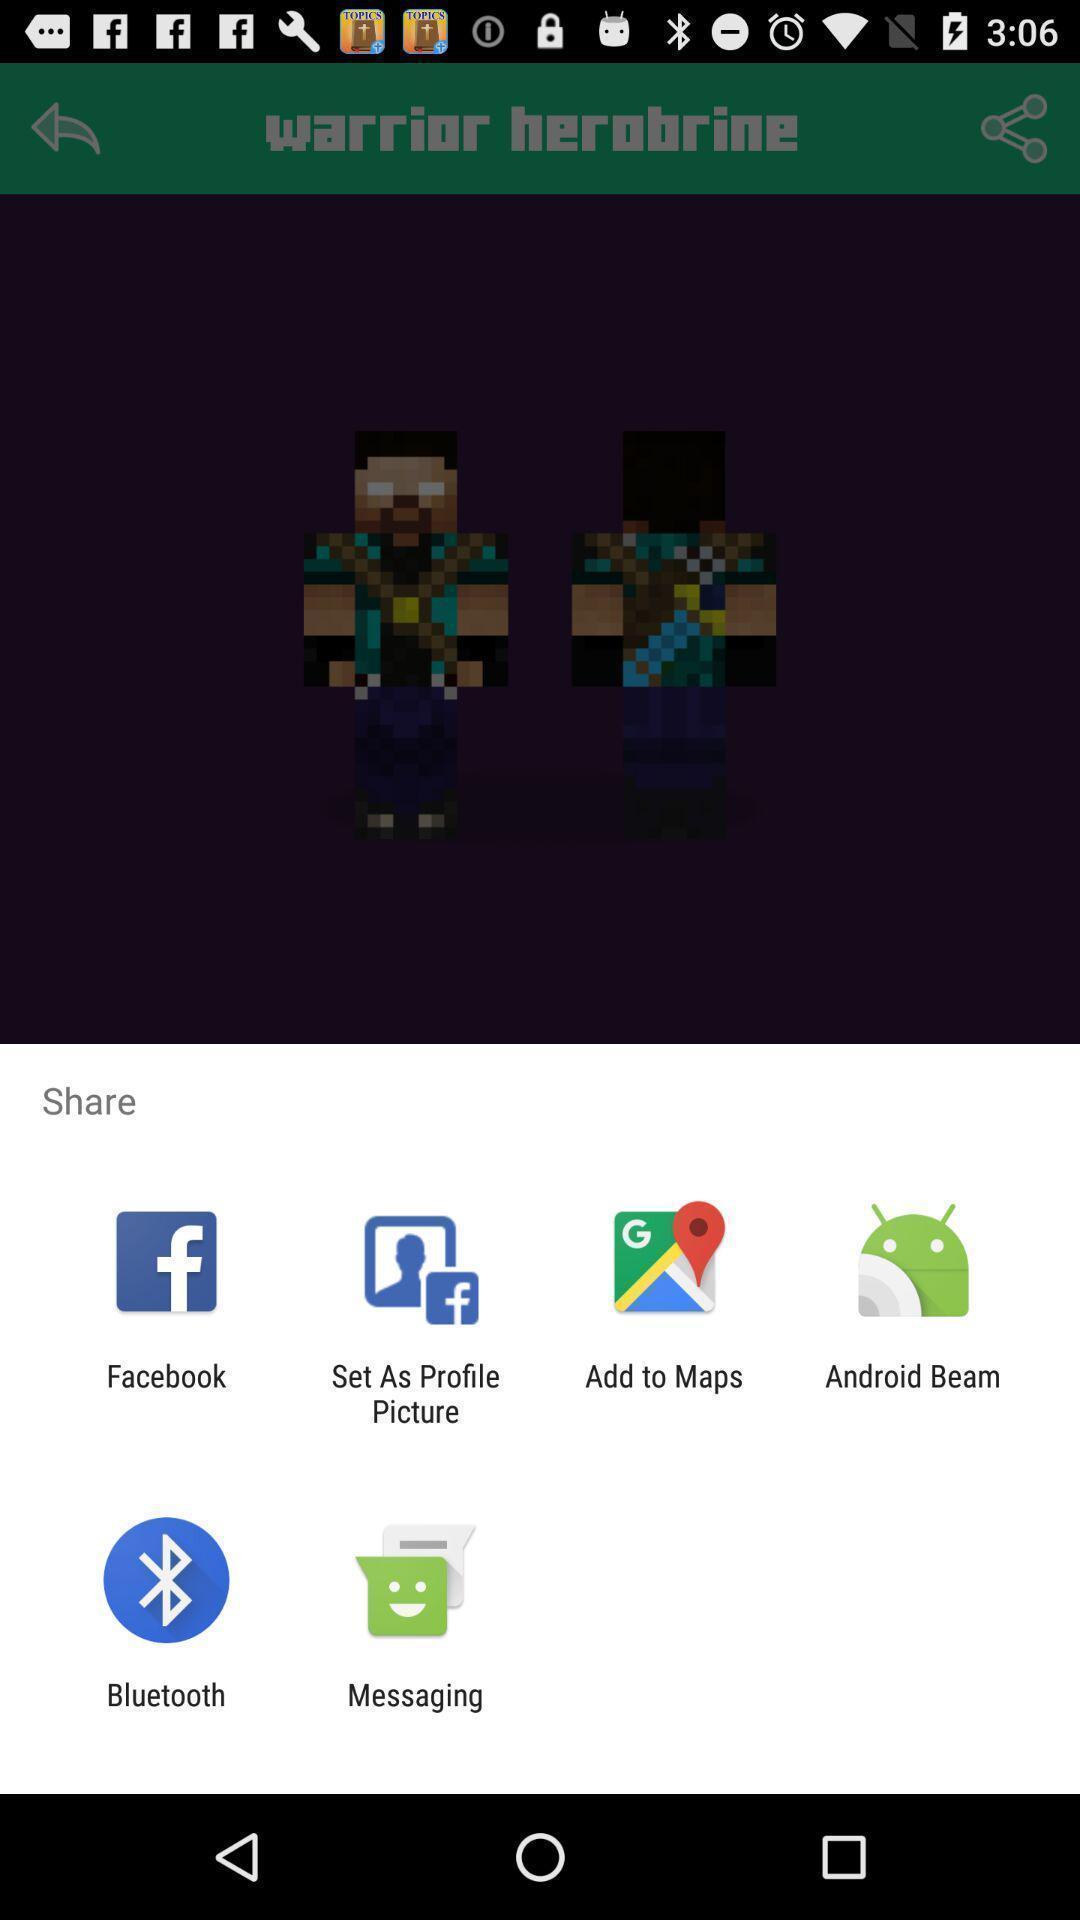Explain what's happening in this screen capture. Push up message with multiple sharing options. 